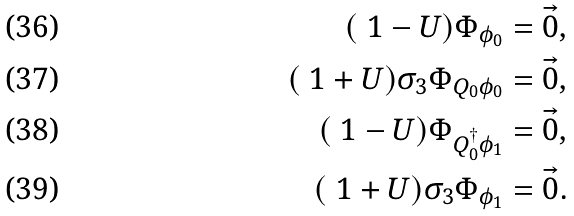<formula> <loc_0><loc_0><loc_500><loc_500>( \ 1 - U ) \Phi _ { \phi _ { 0 } } & = \vec { 0 } , \\ ( \ 1 + U ) \sigma _ { 3 } \Phi _ { Q _ { 0 } \phi _ { 0 } } & = \vec { 0 } , \\ ( \ 1 - U ) \Phi _ { Q _ { 0 } ^ { \dagger } \phi _ { 1 } } & = \vec { 0 } , \\ ( \ 1 + U ) \sigma _ { 3 } \Phi _ { \phi _ { 1 } } & = \vec { 0 } .</formula> 